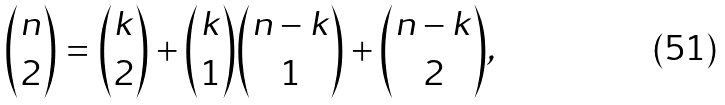<formula> <loc_0><loc_0><loc_500><loc_500>\binom { n } { 2 } = \binom { k } { 2 } + \binom { k } { 1 } \binom { n - k } { 1 } + \binom { n - k } { 2 } ,</formula> 